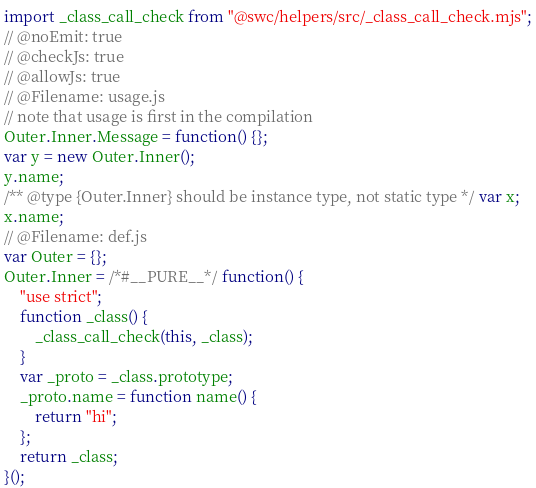<code> <loc_0><loc_0><loc_500><loc_500><_JavaScript_>import _class_call_check from "@swc/helpers/src/_class_call_check.mjs";
// @noEmit: true
// @checkJs: true
// @allowJs: true
// @Filename: usage.js
// note that usage is first in the compilation
Outer.Inner.Message = function() {};
var y = new Outer.Inner();
y.name;
/** @type {Outer.Inner} should be instance type, not static type */ var x;
x.name;
// @Filename: def.js
var Outer = {};
Outer.Inner = /*#__PURE__*/ function() {
    "use strict";
    function _class() {
        _class_call_check(this, _class);
    }
    var _proto = _class.prototype;
    _proto.name = function name() {
        return "hi";
    };
    return _class;
}();
</code> 